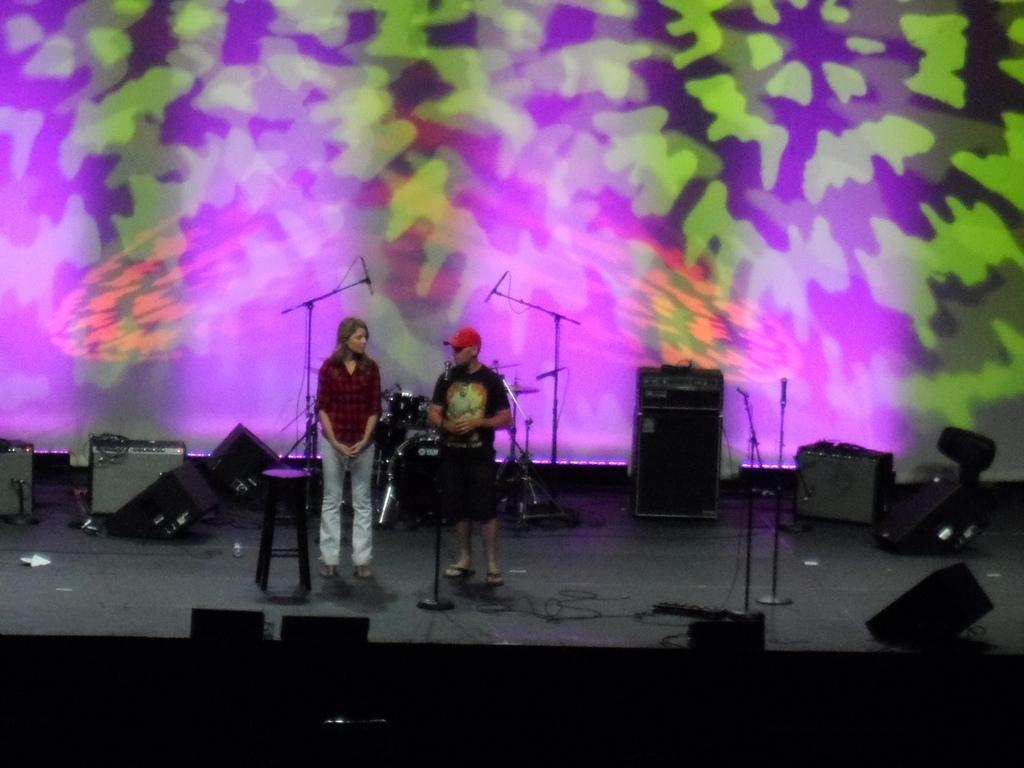Describe this image in one or two sentences. In this picture, we can see a few people, we can see the stage, and some objects on the stage like microphones with stands, speakers, and in the background we can see the screen. 